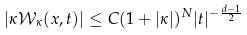Convert formula to latex. <formula><loc_0><loc_0><loc_500><loc_500>| \kappa \mathcal { W } _ { \kappa } ( x , t ) | \leq C ( 1 + | \kappa | ) ^ { N } | t | ^ { - \frac { d - 1 } 2 }</formula> 